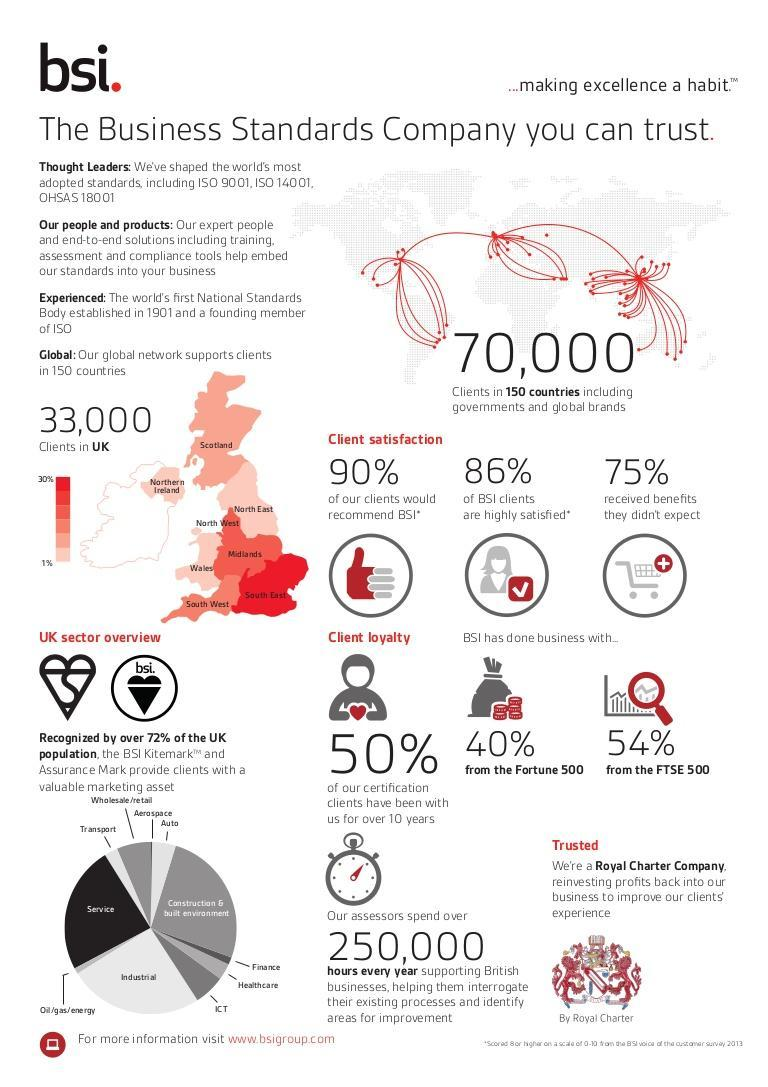What percentage of BSI clients do not belong to the highly satisfied category?
Answer the question with a short phrase. 14% What percentage of clients would not recommend BSI? 10% Which parts of the UK are 1% of BSI's clients based from? Northern Ireland, North East, Wales How many categories or sectors does BSI's clients fall into? 11 What percentage of people did not receive benefits from BSI? 25% Where does BSI have 30% percent of its clients located in UK ? South East What percentage of BSI's clients belong to the Fortune 500 and FTSE 500 category? 94% 